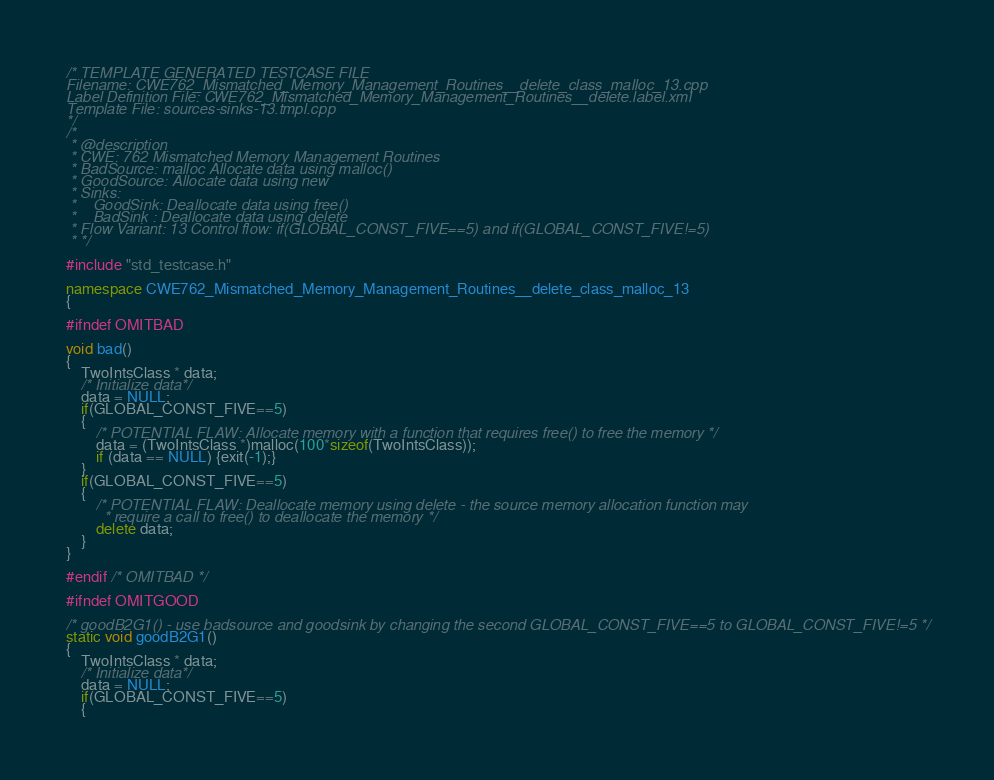Convert code to text. <code><loc_0><loc_0><loc_500><loc_500><_C++_>/* TEMPLATE GENERATED TESTCASE FILE
Filename: CWE762_Mismatched_Memory_Management_Routines__delete_class_malloc_13.cpp
Label Definition File: CWE762_Mismatched_Memory_Management_Routines__delete.label.xml
Template File: sources-sinks-13.tmpl.cpp
*/
/*
 * @description
 * CWE: 762 Mismatched Memory Management Routines
 * BadSource: malloc Allocate data using malloc()
 * GoodSource: Allocate data using new
 * Sinks:
 *    GoodSink: Deallocate data using free()
 *    BadSink : Deallocate data using delete
 * Flow Variant: 13 Control flow: if(GLOBAL_CONST_FIVE==5) and if(GLOBAL_CONST_FIVE!=5)
 * */

#include "std_testcase.h"

namespace CWE762_Mismatched_Memory_Management_Routines__delete_class_malloc_13
{

#ifndef OMITBAD

void bad()
{
    TwoIntsClass * data;
    /* Initialize data*/
    data = NULL;
    if(GLOBAL_CONST_FIVE==5)
    {
        /* POTENTIAL FLAW: Allocate memory with a function that requires free() to free the memory */
        data = (TwoIntsClass *)malloc(100*sizeof(TwoIntsClass));
        if (data == NULL) {exit(-1);}
    }
    if(GLOBAL_CONST_FIVE==5)
    {
        /* POTENTIAL FLAW: Deallocate memory using delete - the source memory allocation function may
         * require a call to free() to deallocate the memory */
        delete data;
    }
}

#endif /* OMITBAD */

#ifndef OMITGOOD

/* goodB2G1() - use badsource and goodsink by changing the second GLOBAL_CONST_FIVE==5 to GLOBAL_CONST_FIVE!=5 */
static void goodB2G1()
{
    TwoIntsClass * data;
    /* Initialize data*/
    data = NULL;
    if(GLOBAL_CONST_FIVE==5)
    {</code> 